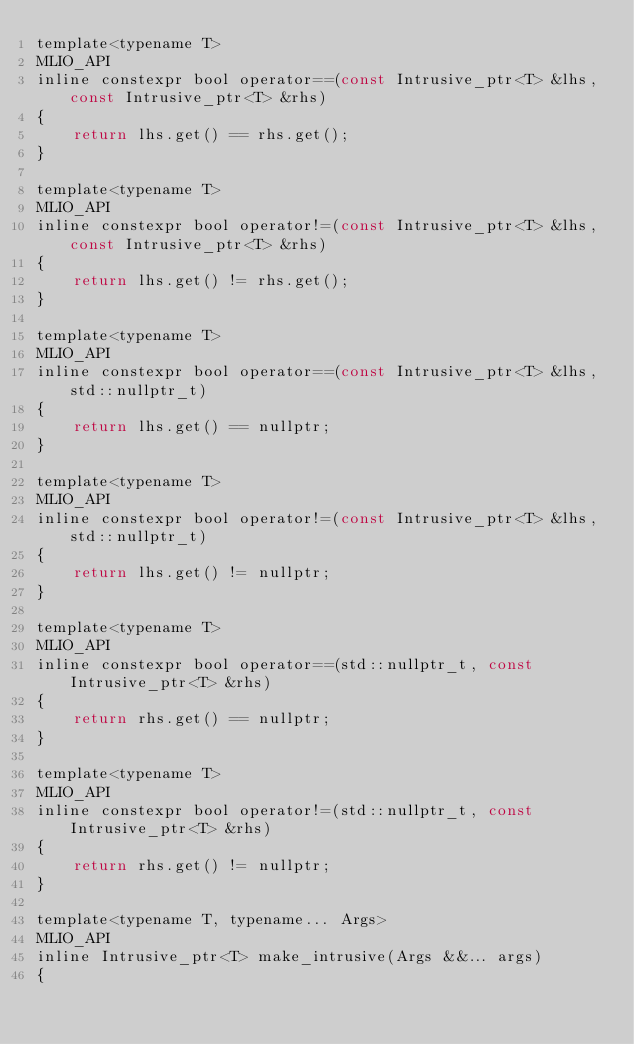Convert code to text. <code><loc_0><loc_0><loc_500><loc_500><_C_>template<typename T>
MLIO_API
inline constexpr bool operator==(const Intrusive_ptr<T> &lhs, const Intrusive_ptr<T> &rhs)
{
    return lhs.get() == rhs.get();
}

template<typename T>
MLIO_API
inline constexpr bool operator!=(const Intrusive_ptr<T> &lhs, const Intrusive_ptr<T> &rhs)
{
    return lhs.get() != rhs.get();
}

template<typename T>
MLIO_API
inline constexpr bool operator==(const Intrusive_ptr<T> &lhs, std::nullptr_t)
{
    return lhs.get() == nullptr;
}

template<typename T>
MLIO_API
inline constexpr bool operator!=(const Intrusive_ptr<T> &lhs, std::nullptr_t)
{
    return lhs.get() != nullptr;
}

template<typename T>
MLIO_API
inline constexpr bool operator==(std::nullptr_t, const Intrusive_ptr<T> &rhs)
{
    return rhs.get() == nullptr;
}

template<typename T>
MLIO_API
inline constexpr bool operator!=(std::nullptr_t, const Intrusive_ptr<T> &rhs)
{
    return rhs.get() != nullptr;
}

template<typename T, typename... Args>
MLIO_API
inline Intrusive_ptr<T> make_intrusive(Args &&... args)
{</code> 